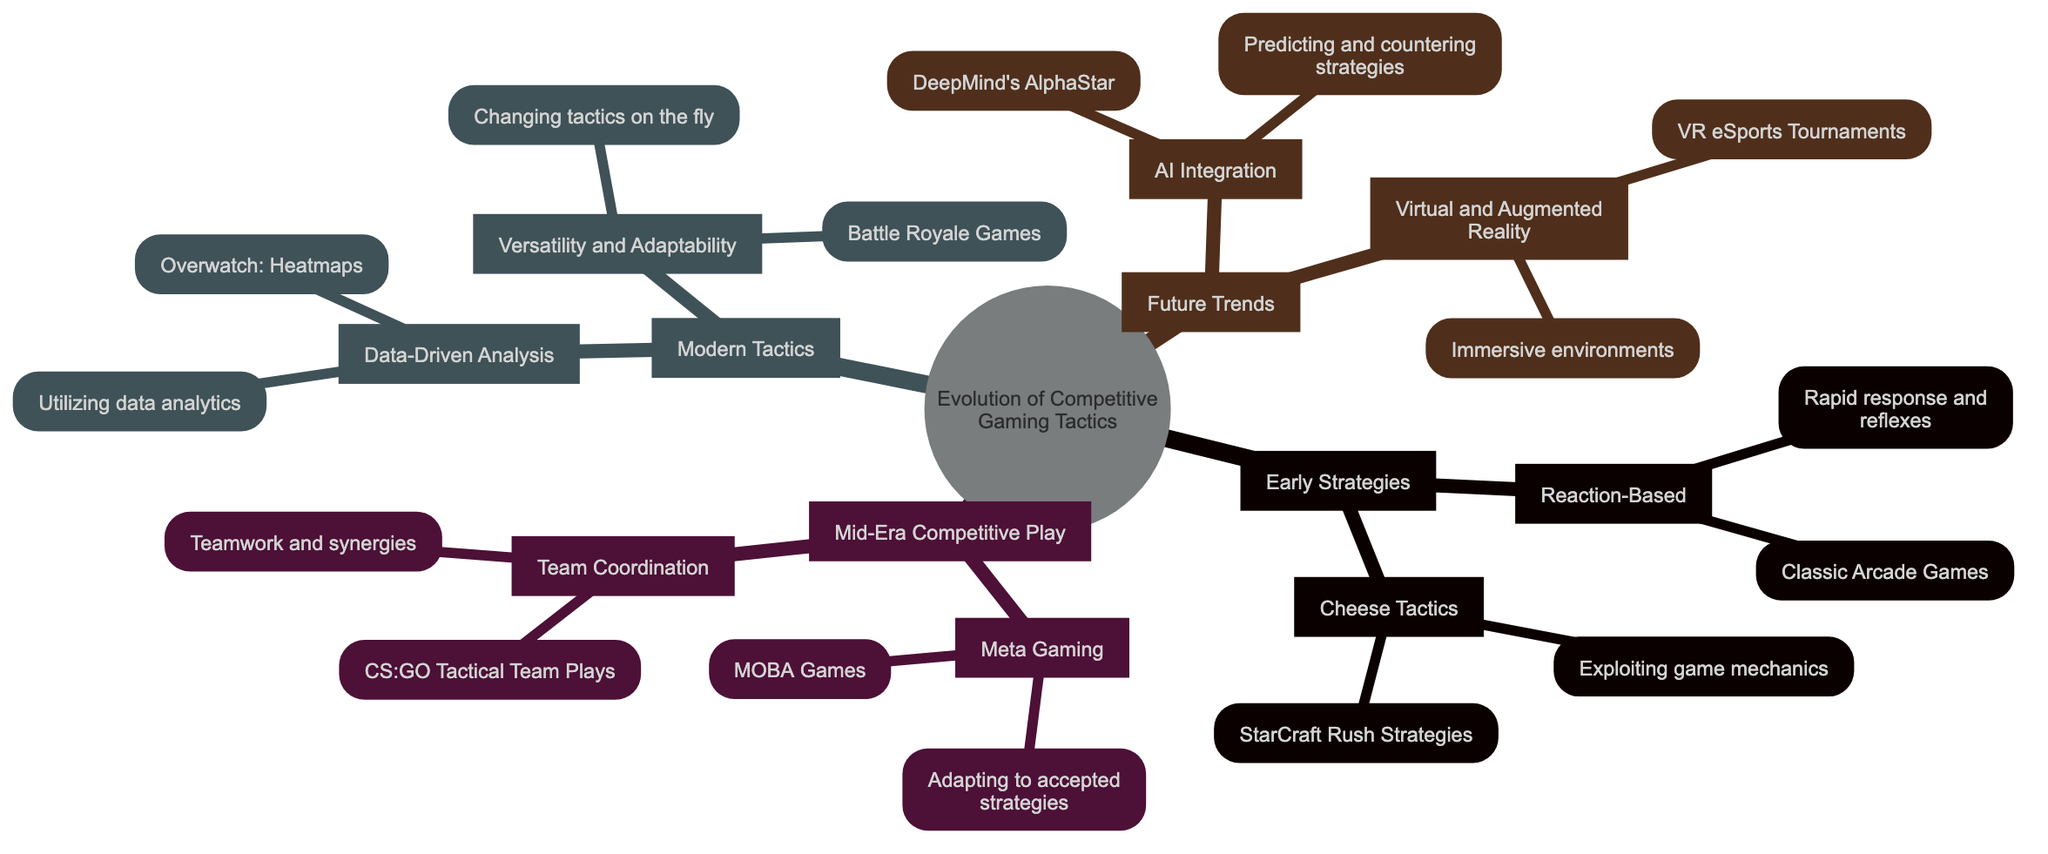What is the title of the mind map? The title is explicitly stated at the top of the diagram as "Evolution of Competitive Gaming Tactics".
Answer: Evolution of Competitive Gaming Tactics How many main nodes are there in the diagram? The diagram contains four main nodes labeled Early Strategies, Mid-Era Competitive Play, Modern Tactics, and Future Trends. Counting these, we find there are four main nodes.
Answer: 4 What strategy is an example of cheese tactics? Cheese tactics are characterized by exploiting game mechanics for quick victories, with StarCraft Rush Strategies being a specific example mentioned.
Answer: StarCraft Rush Strategies Which main node includes data-driven analysis? Data-Driven Analysis is a sub-node found under the Modern Tactics main node, indicating it belongs to this category of competitive gaming tactics.
Answer: Modern Tactics What is a key feature of 'AI Integration' under Future Trends? The 'AI Integration' sub-node highlights the usage of AI to predict and counter strategies, showcasing its advanced role in competitive gaming.
Answer: Predicting and countering strategies How does Team Coordination compare to Meta Gaming? Both strategies emphasize different aspects of competitive play; while Team Coordination focuses on teamwork and synergies, Meta Gaming revolves around adapting to established strategies. Thus, their focus is fundamentally different.
Answer: Different focuses What type of games are representatives of flexibility in Modern Tactics? In modern tactics, 'Versatility and Adaptability' is demonstrated in Battle Royale Games like Fortnite and PUBG, which require players to adjust their strategies based on the evolving gameplay environment.
Answer: Battle Royale Games How does the diagram depict the relationship between Early Strategies and Modern Tactics? The diagram shows that Early Strategies serve as a foundation for the evolution of gaming tactics, transitioning to more complex strategies like those indicated in Modern Tactics, illustrating a development over time.
Answer: Foundation for evolution 